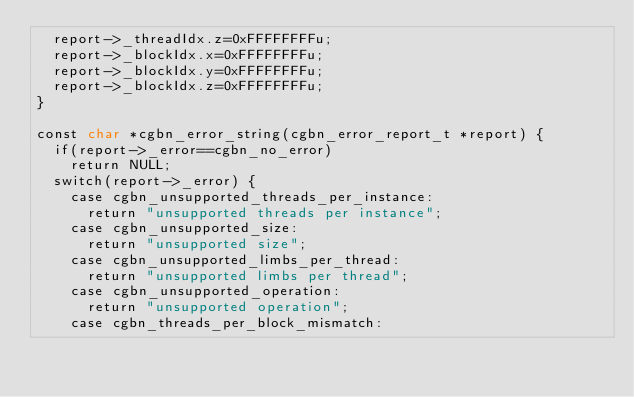<code> <loc_0><loc_0><loc_500><loc_500><_Cuda_>  report->_threadIdx.z=0xFFFFFFFFu;
  report->_blockIdx.x=0xFFFFFFFFu;
  report->_blockIdx.y=0xFFFFFFFFu;
  report->_blockIdx.z=0xFFFFFFFFu;
}

const char *cgbn_error_string(cgbn_error_report_t *report) {
  if(report->_error==cgbn_no_error)
    return NULL;
  switch(report->_error) {
    case cgbn_unsupported_threads_per_instance:
      return "unsupported threads per instance";
    case cgbn_unsupported_size:
      return "unsupported size";
    case cgbn_unsupported_limbs_per_thread:
      return "unsupported limbs per thread";
    case cgbn_unsupported_operation:
      return "unsupported operation";
    case cgbn_threads_per_block_mismatch:</code> 